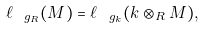<formula> <loc_0><loc_0><loc_500><loc_500>\ell _ { \ g _ { R } } ( M ) = \ell _ { \ g _ { k } } ( k \otimes _ { R } M ) ,</formula> 